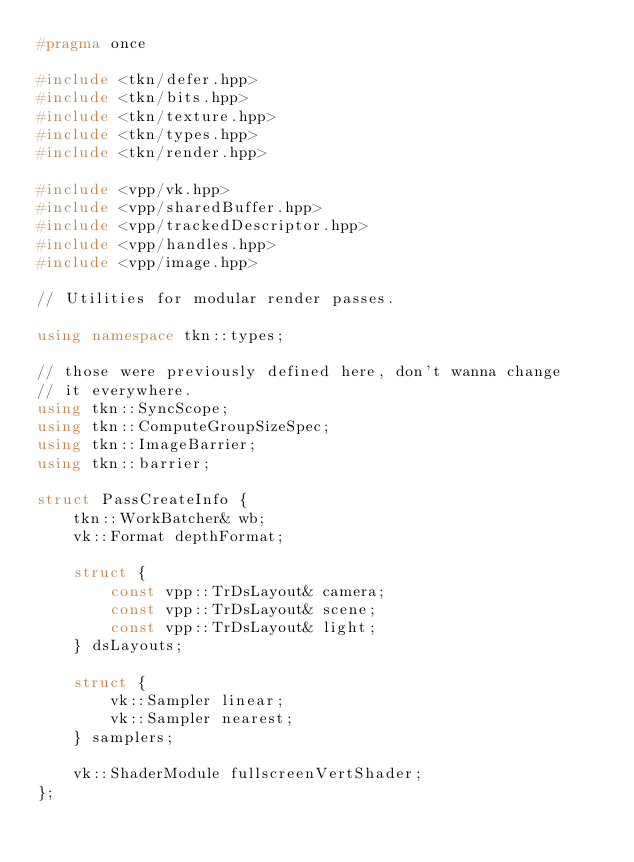<code> <loc_0><loc_0><loc_500><loc_500><_C++_>#pragma once

#include <tkn/defer.hpp>
#include <tkn/bits.hpp>
#include <tkn/texture.hpp>
#include <tkn/types.hpp>
#include <tkn/render.hpp>

#include <vpp/vk.hpp>
#include <vpp/sharedBuffer.hpp>
#include <vpp/trackedDescriptor.hpp>
#include <vpp/handles.hpp>
#include <vpp/image.hpp>

// Utilities for modular render passes.

using namespace tkn::types;

// those were previously defined here, don't wanna change
// it everywhere.
using tkn::SyncScope;
using tkn::ComputeGroupSizeSpec;
using tkn::ImageBarrier;
using tkn::barrier;

struct PassCreateInfo {
	tkn::WorkBatcher& wb;
	vk::Format depthFormat;

	struct {
		const vpp::TrDsLayout& camera;
		const vpp::TrDsLayout& scene;
		const vpp::TrDsLayout& light;
	} dsLayouts;

	struct {
		vk::Sampler linear;
		vk::Sampler nearest;
	} samplers;

	vk::ShaderModule fullscreenVertShader;
};

</code> 